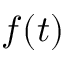<formula> <loc_0><loc_0><loc_500><loc_500>f ( t )</formula> 